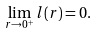<formula> <loc_0><loc_0><loc_500><loc_500>\lim _ { r \rightarrow 0 ^ { + } } l ( r ) = 0 .</formula> 